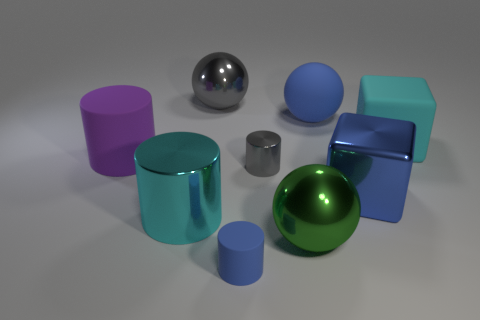Subtract all rubber spheres. How many spheres are left? 2 Add 1 large yellow matte balls. How many objects exist? 10 Subtract all gray spheres. How many spheres are left? 2 Subtract all cylinders. How many objects are left? 5 Subtract 1 spheres. How many spheres are left? 2 Subtract all gray cylinders. Subtract all red cubes. How many cylinders are left? 3 Subtract all small gray balls. Subtract all blue matte spheres. How many objects are left? 8 Add 4 small blue matte cylinders. How many small blue matte cylinders are left? 5 Add 4 cyan shiny cylinders. How many cyan shiny cylinders exist? 5 Subtract 0 brown spheres. How many objects are left? 9 